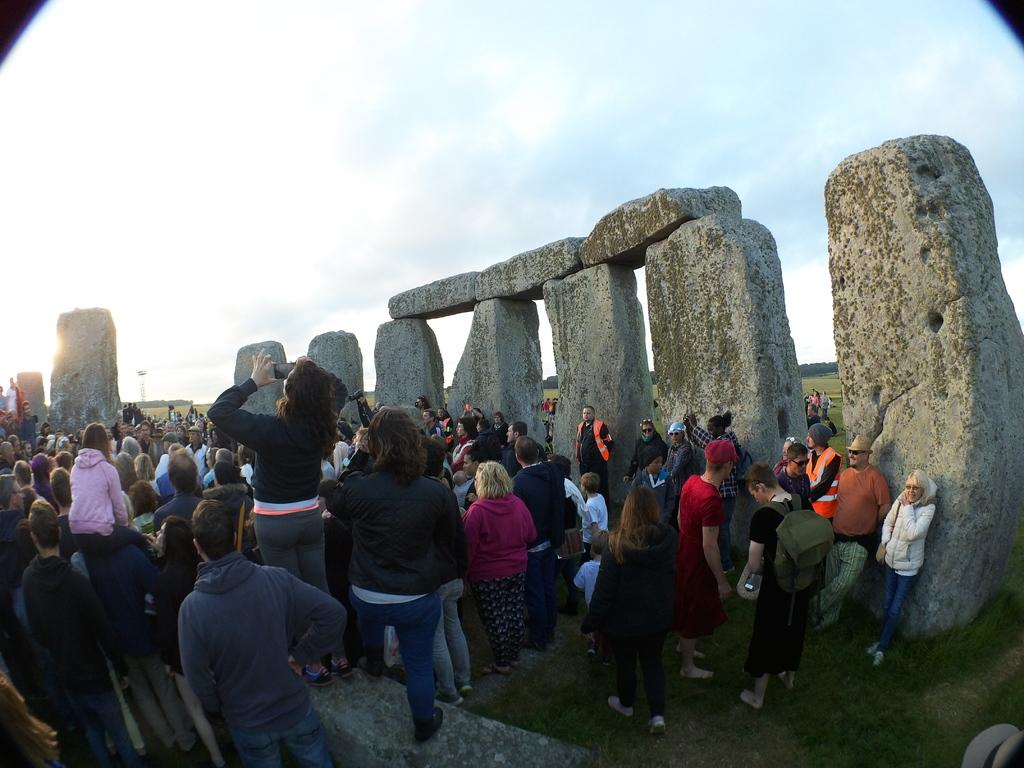How many people are in the image? There is a group of people in the image. What is the position of the people in the image? The people are standing on the ground. What can be seen in the background of the image? There are stones and the sky visible in the background of the image. What else is present in the background of the image? There are other objects present in the background of the image. What is the relation between the people and the bikes in the image? There are no bikes present in the image, so there is no relation between the people and bikes. 